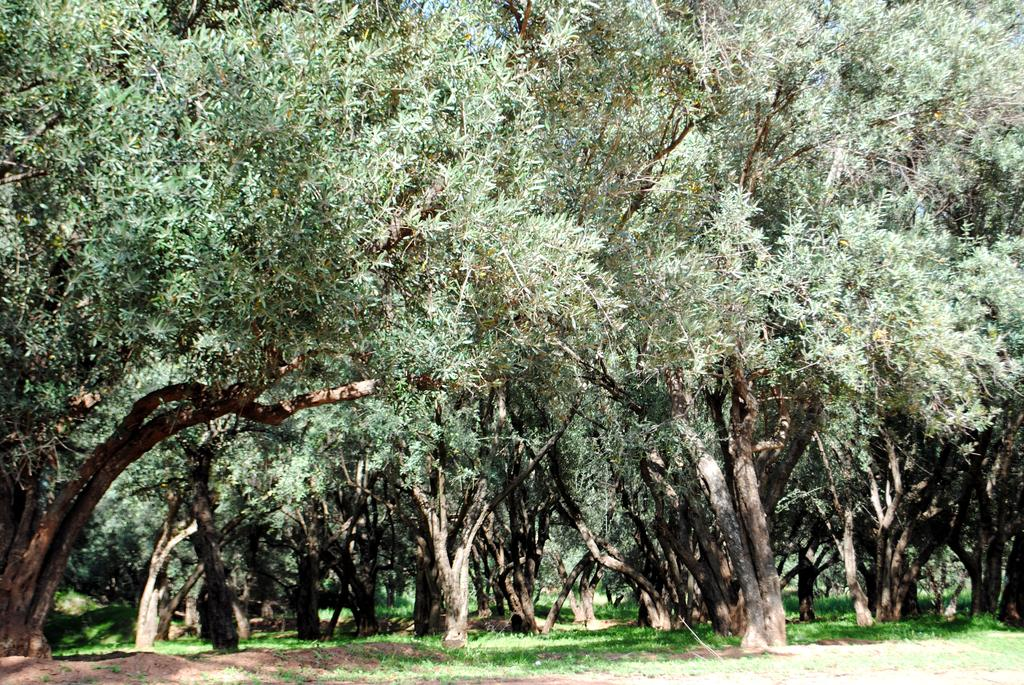What type of ground is visible in the image? There is grass ground in the image. What other natural elements can be seen in the image? There are trees in the image. What type of pie is being served on the grass in the image? There is no pie present in the image; it only features grass ground and trees. 